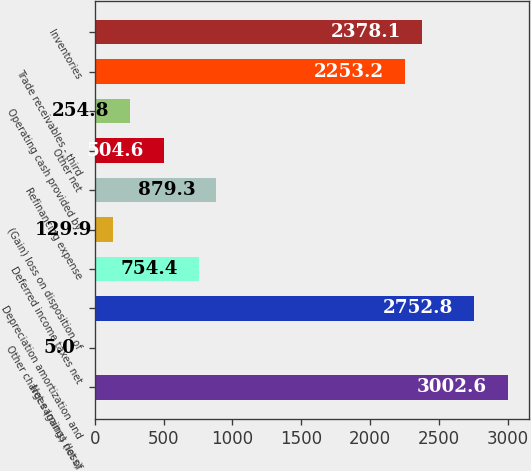<chart> <loc_0><loc_0><loc_500><loc_500><bar_chart><fcel>Net earnings (loss)<fcel>Other charges (gains) net of<fcel>Depreciation amortization and<fcel>Deferred income taxes net<fcel>(Gain) loss on disposition of<fcel>Refinancing expense<fcel>Other net<fcel>Operating cash provided by<fcel>Trade receivables - third<fcel>Inventories<nl><fcel>3002.6<fcel>5<fcel>2752.8<fcel>754.4<fcel>129.9<fcel>879.3<fcel>504.6<fcel>254.8<fcel>2253.2<fcel>2378.1<nl></chart> 